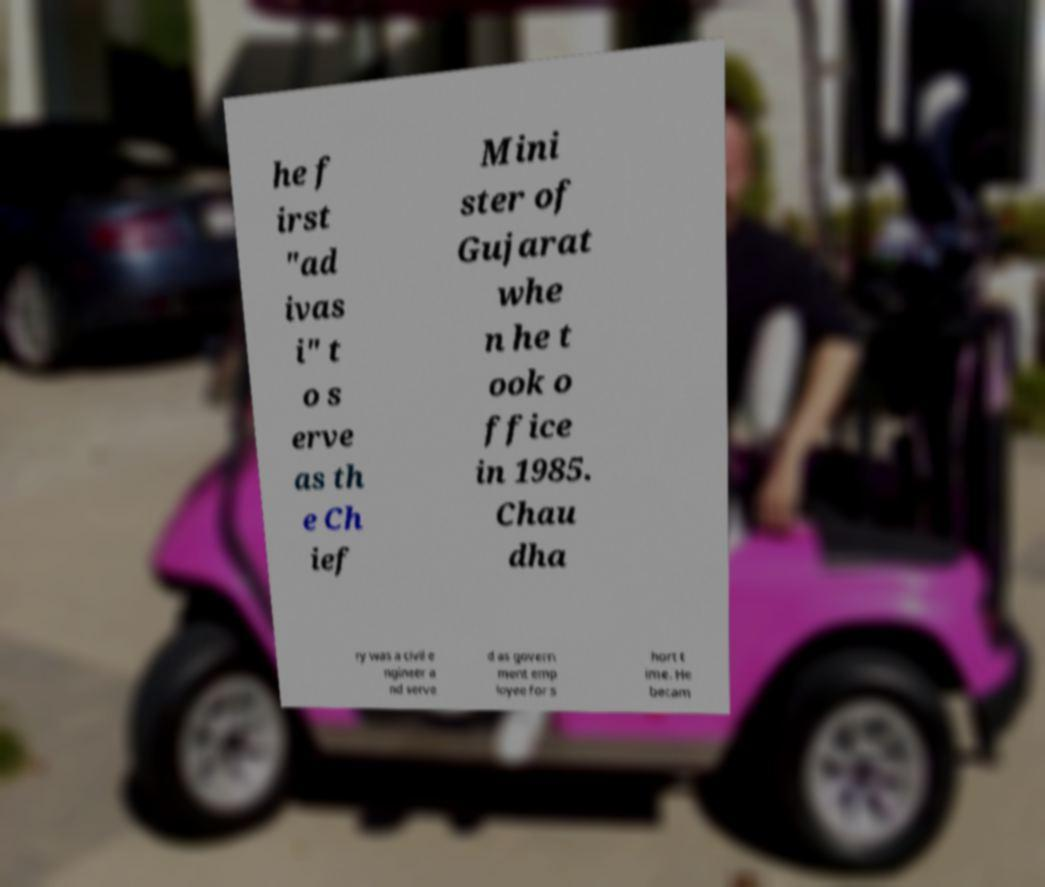Can you read and provide the text displayed in the image?This photo seems to have some interesting text. Can you extract and type it out for me? he f irst "ad ivas i" t o s erve as th e Ch ief Mini ster of Gujarat whe n he t ook o ffice in 1985. Chau dha ry was a civil e ngineer a nd serve d as govern ment emp loyee for s hort t ime. He becam 